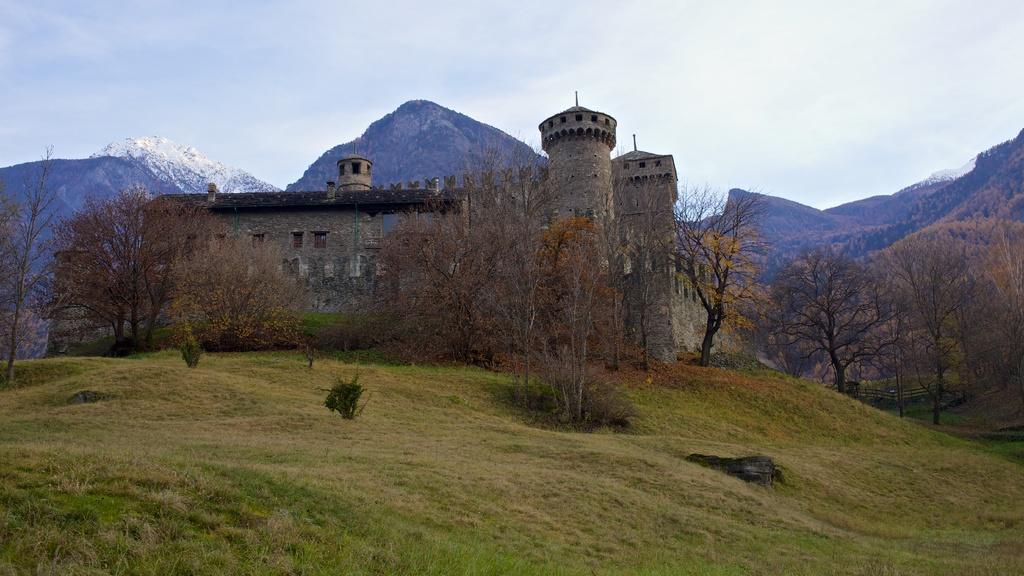Please provide a concise description of this image. In this picture there is a monument. In the background we can see the snow mountains. At the top we can see sky and clouds. On the right we can see many trees. At the bottom we can see plants and grass. On the monument we can see the windows. 